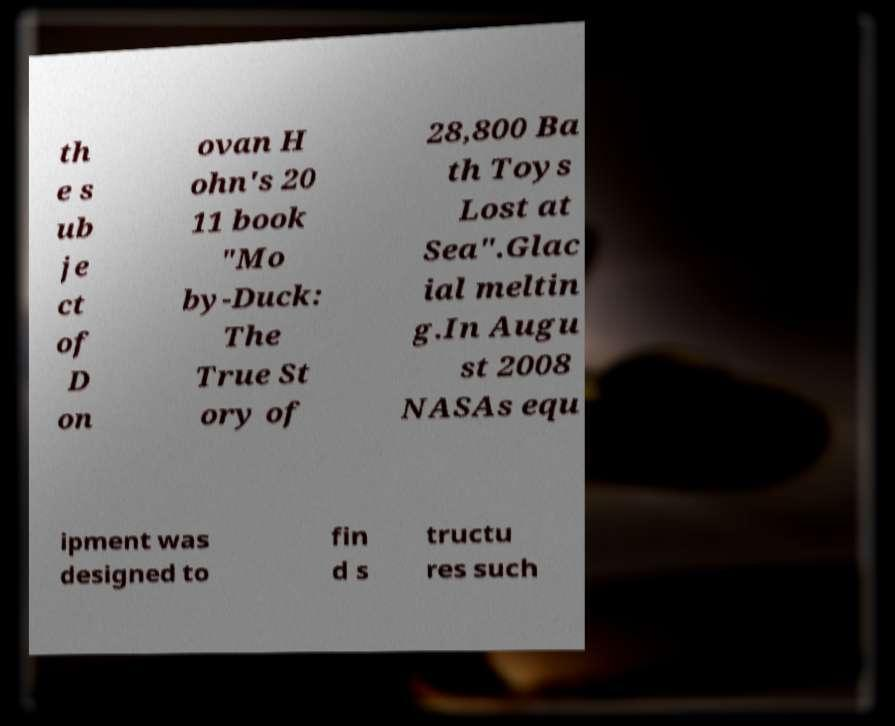There's text embedded in this image that I need extracted. Can you transcribe it verbatim? th e s ub je ct of D on ovan H ohn's 20 11 book "Mo by-Duck: The True St ory of 28,800 Ba th Toys Lost at Sea".Glac ial meltin g.In Augu st 2008 NASAs equ ipment was designed to fin d s tructu res such 